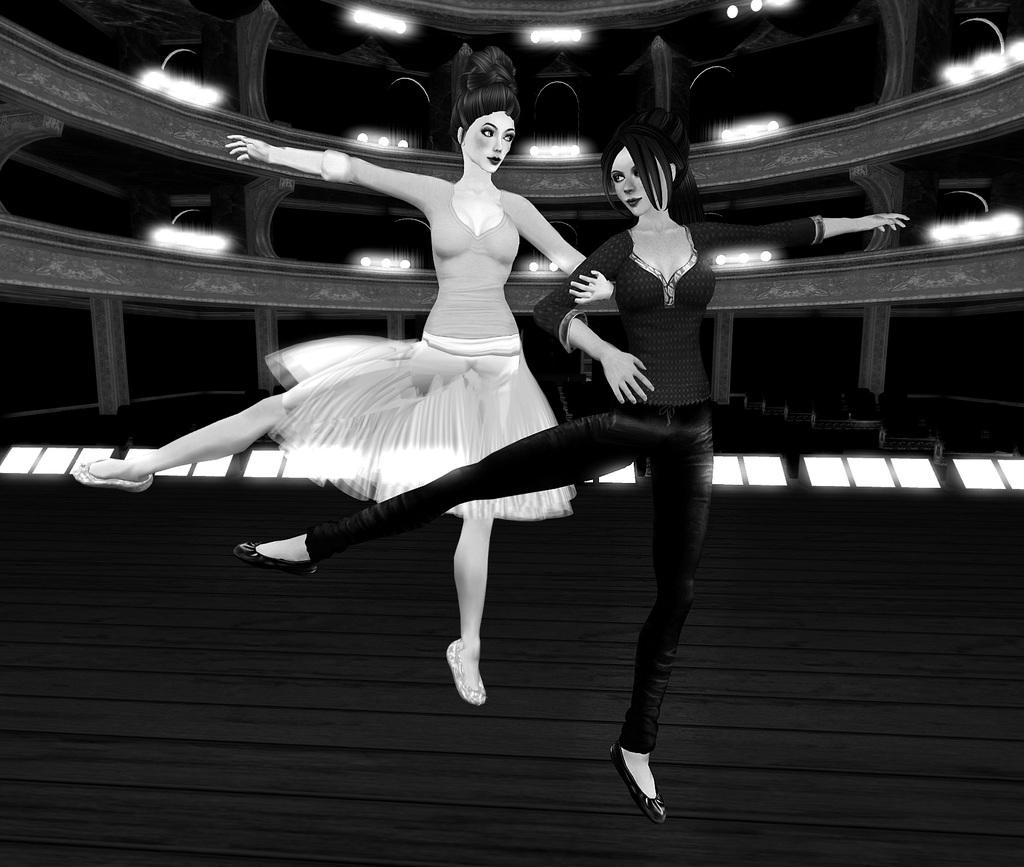How many people are in the image? There are two girls in the image. What are the girls doing in the image? The girls are dancing. How are the girls interacting with each other? The girls are holding each other's hands. What can be seen in the background of the image? There is an animated stadium building in the background. What features does the stadium building have? The stadium building has seats and lights. What type of cushion is being used by the girls to dance in the image? There is no cushion visible in the image; the girls are dancing without any additional support. Can you tell me how many clouds are present in the image? There are no clouds visible in the image; the focus is on the girls dancing and the stadium building in the background. 